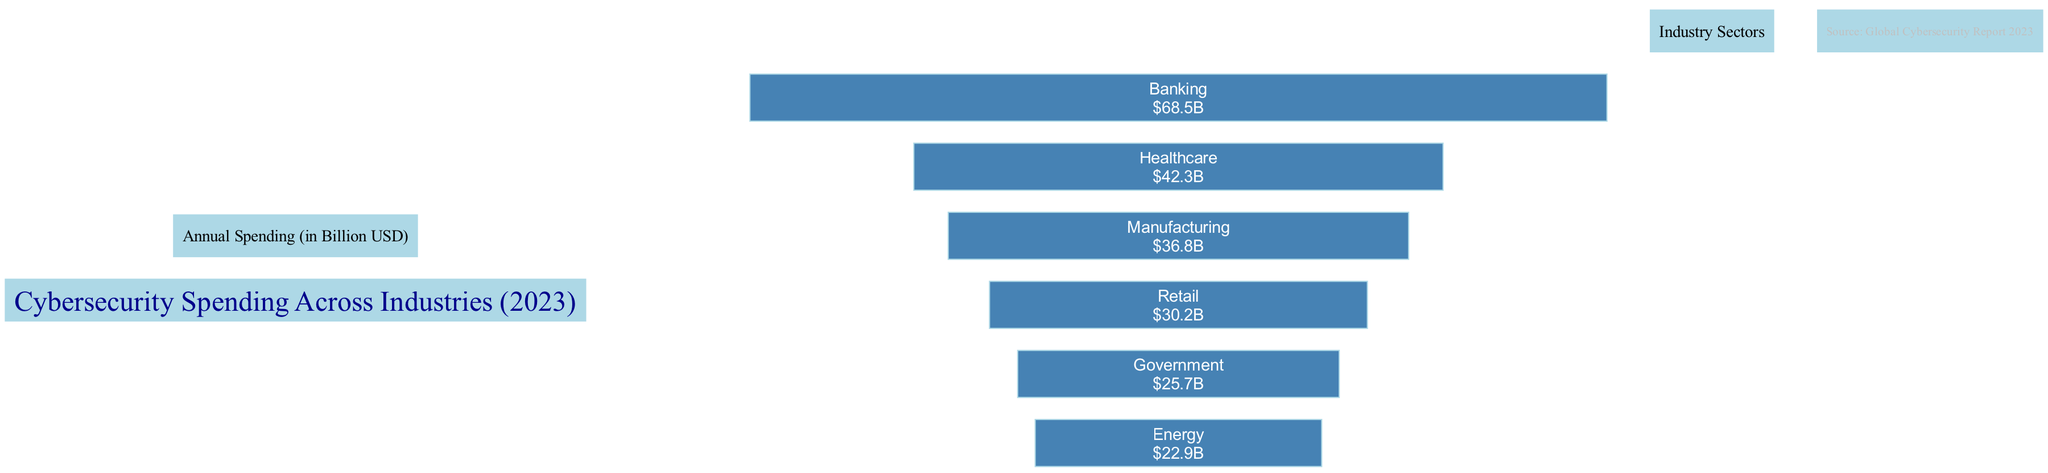What is the highest cybersecurity spending industry? By examining the bar graph, the tallest bar corresponds to the Banking sector, which indicates that it has the highest annual cybersecurity spending among the listed industries.
Answer: Banking How much does the Healthcare industry spend on cybersecurity? The bar representing the Healthcare industry indicates that its annual spending on cybersecurity is 42.3 billion USD.
Answer: 42.3 billion USD Which industry spends the least on cybersecurity? Looking at the bars, the Government sector has the shortest bar, indicating it spends the least on cybersecurity compared to the other industries shown.
Answer: Government What is the total annual spending on cybersecurity by Retail and Energy industries combined? Adding the spending figures: Retail (30.2 billion USD) + Energy (22.9 billion USD) gives a combined total of 53.1 billion USD in cybersecurity spending for these two industries.
Answer: 53.1 billion USD What is the difference in cybersecurity spending between Banking and Government? The banking industry spends 68.5 billion USD, while the government spends 25.7 billion USD. The difference is calculated as 68.5 - 25.7 = 42.8 billion USD.
Answer: 42.8 billion USD 